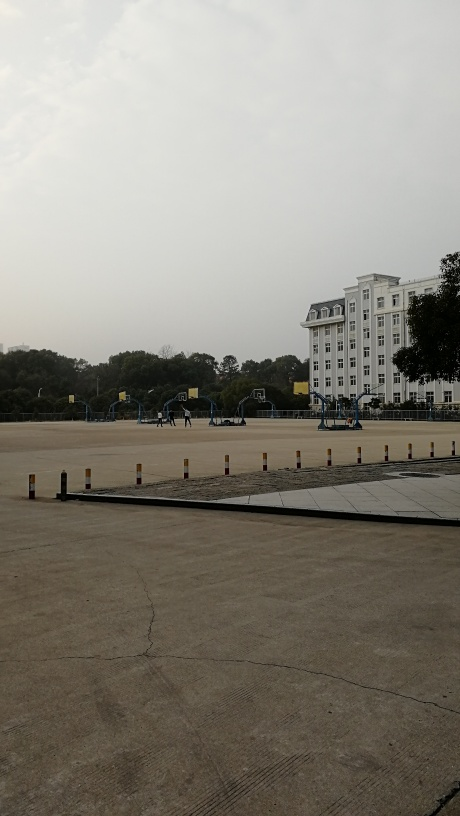Could you describe the architectural style of the building? The architectural style of the building is neoclassical, as evidenced by its symmetrical facade, white columns, and use of rectangular windows. The overall design conveys a sense of formality and grandeur, commonly found in buildings of historical or institutional significance. What might be the function of this building based on its design? Based on the neoclassical design and the structured surroundings, it's plausible that the building serves an educational or administrative function. Such buildings are often associated with universities, schools, courthouses, or government offices. 